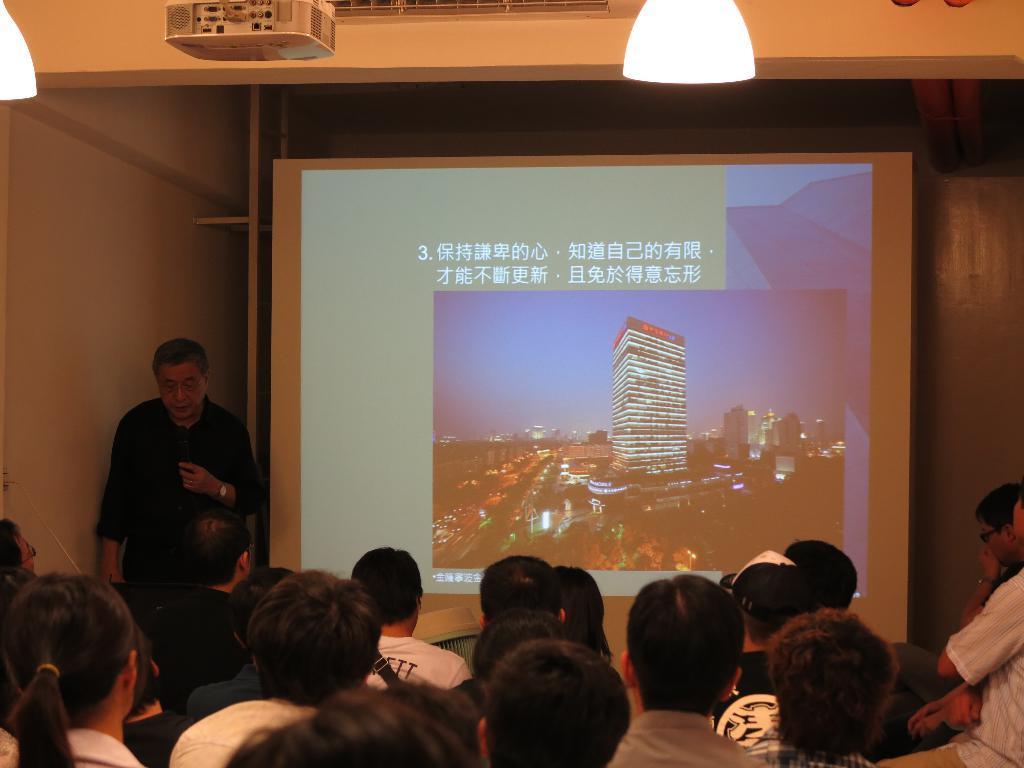How would you summarize this image in a sentence or two? In this picture we can see a group of people sitting and a man in the black shirt is holding a microphone and standing. On the right side of the man there is a projector screen. At the top there is a projector and lights, and behind the projector there's a wall. 